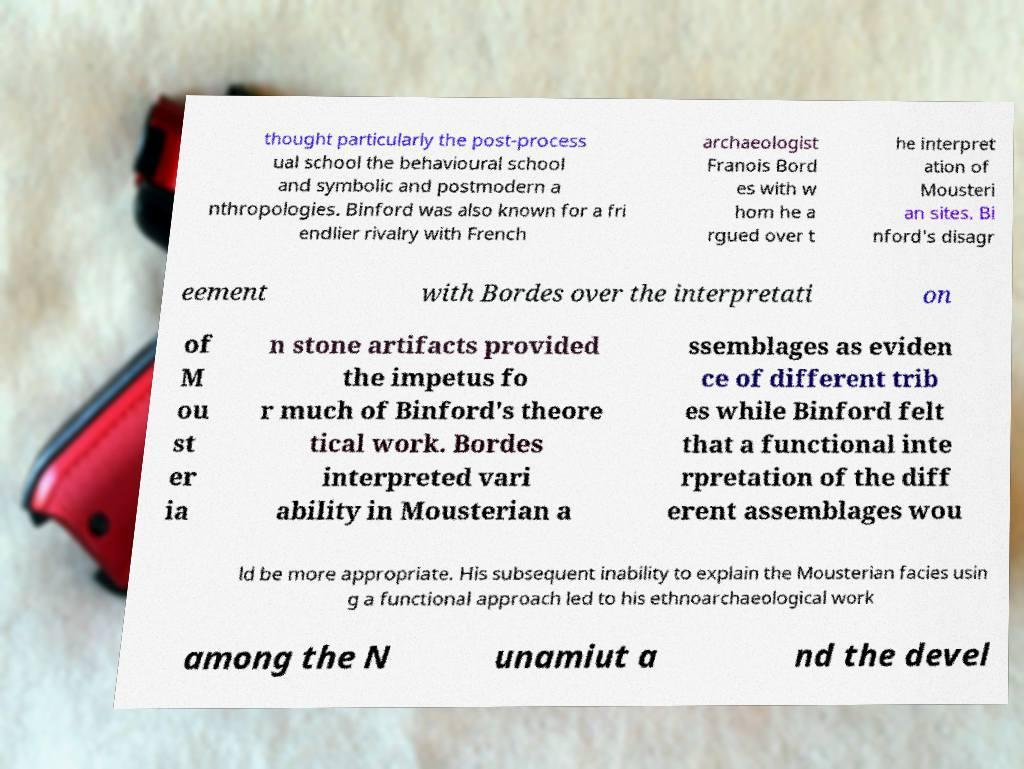Please identify and transcribe the text found in this image. thought particularly the post-process ual school the behavioural school and symbolic and postmodern a nthropologies. Binford was also known for a fri endlier rivalry with French archaeologist Franois Bord es with w hom he a rgued over t he interpret ation of Mousteri an sites. Bi nford's disagr eement with Bordes over the interpretati on of M ou st er ia n stone artifacts provided the impetus fo r much of Binford's theore tical work. Bordes interpreted vari ability in Mousterian a ssemblages as eviden ce of different trib es while Binford felt that a functional inte rpretation of the diff erent assemblages wou ld be more appropriate. His subsequent inability to explain the Mousterian facies usin g a functional approach led to his ethnoarchaeological work among the N unamiut a nd the devel 